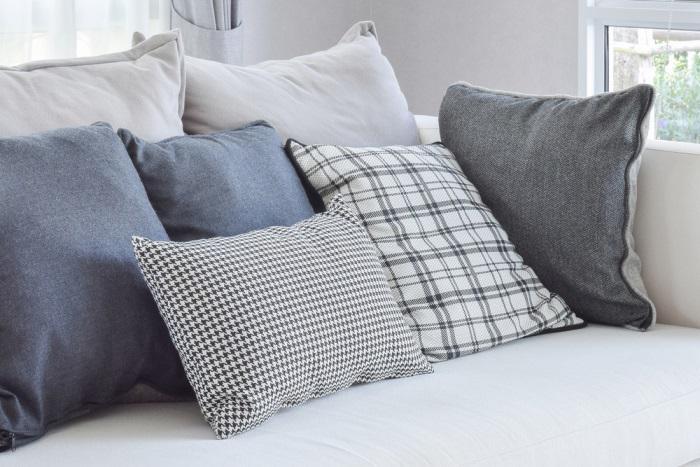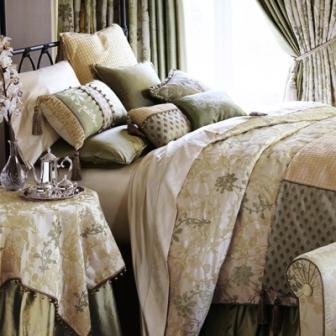The first image is the image on the left, the second image is the image on the right. Evaluate the accuracy of this statement regarding the images: "There are more than 5 frames on the wall in the image on the left.". Is it true? Answer yes or no. No. 